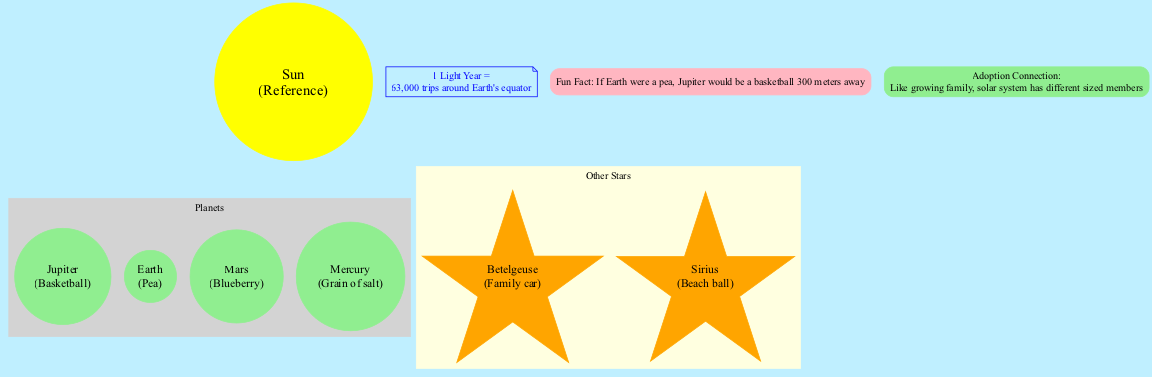What is the size comparison for Jupiter? The diagram indicates that Jupiter is represented as a "Basketball." This information is found in the section listing the planets, which gives each planet's size comparison relative to common objects.
Answer: Basketball How many planets are shown in the diagram? The diagram lists a total of four planets, namely Jupiter, Earth, Mars, and Mercury. Each is specifically included under the "Planets" section of the diagram.
Answer: 4 Which star is compared to a family car? The diagram shows that the star "Betelgeuse" is compared to a "Family car." This reference is made in the section dedicated to stars, highlighting each star's size comparison.
Answer: Betelgeuse What does the distance scale indicate for 1 light year? According to the diagram, "1 Light Year" is represented as "63,000 trips around Earth's equator." This information is shown in a separate node dedicated to distance scale.
Answer: 63,000 trips around Earth's equator If Earth is a pea, how far away is Jupiter represented in the diagram? The fun fact in the diagram states that if Earth were a pea, Jupiter would be a basketball positioned "300 meters away." This reveals a unique perspective on the vast distances in the solar system.
Answer: 300 meters What is the fun fact provided in the diagram? The fun fact stated in the diagram is: "If Earth were a pea, Jupiter would be a basketball 300 meters away." This information is presented in a box labeled "Fun Fact."
Answer: If Earth were a pea, Jupiter would be a basketball 300 meters away Which object represents Mercury's size in the diagram? Mercury is represented as a "Grain of salt" in the diagram. This can be found in the section that lists the planets along with their respective size comparisons.
Answer: Grain of salt What is the adoption connection highlighted in the diagram? The diagram indicates that the adoption connection is: "Like growing family, solar system has different sized members." This note is included as a part of the overall theme of the diagram.
Answer: Like growing family, solar system has different sized members 